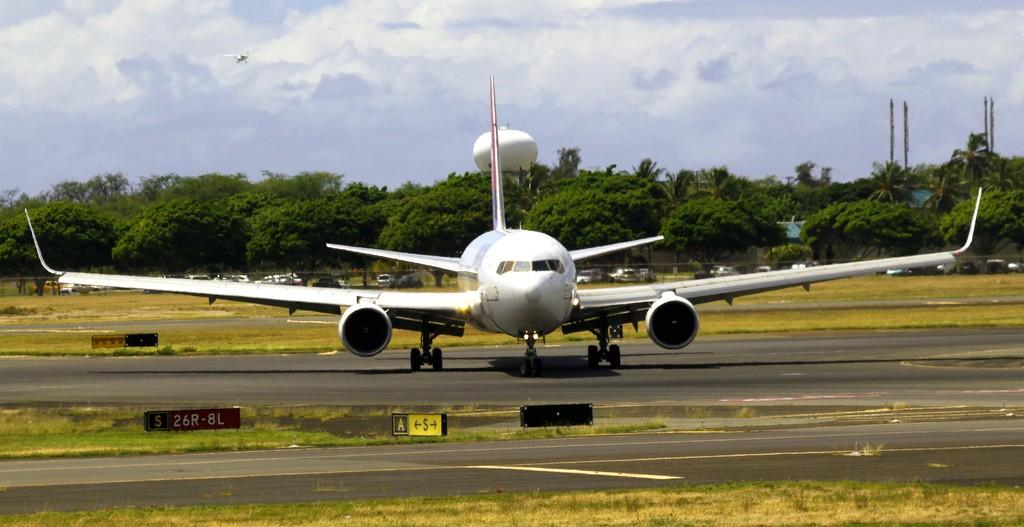<image>
Create a compact narrative representing the image presented. A plan is on the runway near a small sign that has the letters A and S on it. 